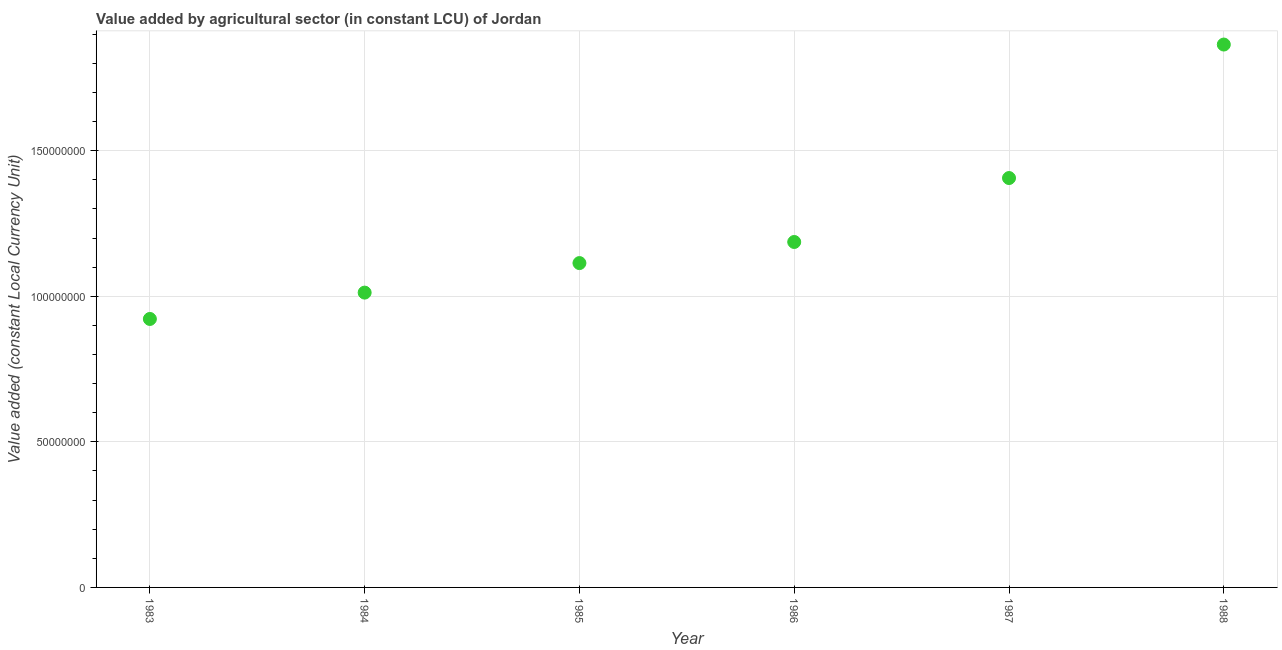What is the value added by agriculture sector in 1985?
Your answer should be compact. 1.11e+08. Across all years, what is the maximum value added by agriculture sector?
Offer a very short reply. 1.86e+08. Across all years, what is the minimum value added by agriculture sector?
Provide a succinct answer. 9.22e+07. In which year was the value added by agriculture sector minimum?
Keep it short and to the point. 1983. What is the sum of the value added by agriculture sector?
Your answer should be very brief. 7.51e+08. What is the difference between the value added by agriculture sector in 1986 and 1988?
Your answer should be compact. -6.78e+07. What is the average value added by agriculture sector per year?
Your response must be concise. 1.25e+08. What is the median value added by agriculture sector?
Provide a succinct answer. 1.15e+08. In how many years, is the value added by agriculture sector greater than 120000000 LCU?
Your answer should be compact. 2. What is the ratio of the value added by agriculture sector in 1985 to that in 1986?
Give a very brief answer. 0.94. Is the value added by agriculture sector in 1986 less than that in 1987?
Your response must be concise. Yes. Is the difference between the value added by agriculture sector in 1986 and 1987 greater than the difference between any two years?
Offer a terse response. No. What is the difference between the highest and the second highest value added by agriculture sector?
Your response must be concise. 4.59e+07. Is the sum of the value added by agriculture sector in 1986 and 1987 greater than the maximum value added by agriculture sector across all years?
Give a very brief answer. Yes. What is the difference between the highest and the lowest value added by agriculture sector?
Provide a succinct answer. 9.43e+07. In how many years, is the value added by agriculture sector greater than the average value added by agriculture sector taken over all years?
Offer a very short reply. 2. Does the value added by agriculture sector monotonically increase over the years?
Offer a terse response. Yes. How many dotlines are there?
Your answer should be very brief. 1. How many years are there in the graph?
Your answer should be very brief. 6. What is the title of the graph?
Your response must be concise. Value added by agricultural sector (in constant LCU) of Jordan. What is the label or title of the Y-axis?
Your response must be concise. Value added (constant Local Currency Unit). What is the Value added (constant Local Currency Unit) in 1983?
Give a very brief answer. 9.22e+07. What is the Value added (constant Local Currency Unit) in 1984?
Ensure brevity in your answer.  1.01e+08. What is the Value added (constant Local Currency Unit) in 1985?
Keep it short and to the point. 1.11e+08. What is the Value added (constant Local Currency Unit) in 1986?
Your answer should be very brief. 1.19e+08. What is the Value added (constant Local Currency Unit) in 1987?
Provide a succinct answer. 1.41e+08. What is the Value added (constant Local Currency Unit) in 1988?
Offer a terse response. 1.86e+08. What is the difference between the Value added (constant Local Currency Unit) in 1983 and 1984?
Give a very brief answer. -9.05e+06. What is the difference between the Value added (constant Local Currency Unit) in 1983 and 1985?
Offer a very short reply. -1.92e+07. What is the difference between the Value added (constant Local Currency Unit) in 1983 and 1986?
Offer a terse response. -2.64e+07. What is the difference between the Value added (constant Local Currency Unit) in 1983 and 1987?
Provide a succinct answer. -4.84e+07. What is the difference between the Value added (constant Local Currency Unit) in 1983 and 1988?
Ensure brevity in your answer.  -9.43e+07. What is the difference between the Value added (constant Local Currency Unit) in 1984 and 1985?
Your answer should be very brief. -1.01e+07. What is the difference between the Value added (constant Local Currency Unit) in 1984 and 1986?
Ensure brevity in your answer.  -1.74e+07. What is the difference between the Value added (constant Local Currency Unit) in 1984 and 1987?
Offer a very short reply. -3.94e+07. What is the difference between the Value added (constant Local Currency Unit) in 1984 and 1988?
Your answer should be compact. -8.52e+07. What is the difference between the Value added (constant Local Currency Unit) in 1985 and 1986?
Offer a terse response. -7.25e+06. What is the difference between the Value added (constant Local Currency Unit) in 1985 and 1987?
Your response must be concise. -2.92e+07. What is the difference between the Value added (constant Local Currency Unit) in 1985 and 1988?
Your answer should be compact. -7.51e+07. What is the difference between the Value added (constant Local Currency Unit) in 1986 and 1987?
Keep it short and to the point. -2.20e+07. What is the difference between the Value added (constant Local Currency Unit) in 1986 and 1988?
Your answer should be compact. -6.78e+07. What is the difference between the Value added (constant Local Currency Unit) in 1987 and 1988?
Give a very brief answer. -4.59e+07. What is the ratio of the Value added (constant Local Currency Unit) in 1983 to that in 1984?
Give a very brief answer. 0.91. What is the ratio of the Value added (constant Local Currency Unit) in 1983 to that in 1985?
Provide a succinct answer. 0.83. What is the ratio of the Value added (constant Local Currency Unit) in 1983 to that in 1986?
Your answer should be very brief. 0.78. What is the ratio of the Value added (constant Local Currency Unit) in 1983 to that in 1987?
Your response must be concise. 0.66. What is the ratio of the Value added (constant Local Currency Unit) in 1983 to that in 1988?
Offer a terse response. 0.49. What is the ratio of the Value added (constant Local Currency Unit) in 1984 to that in 1985?
Provide a succinct answer. 0.91. What is the ratio of the Value added (constant Local Currency Unit) in 1984 to that in 1986?
Keep it short and to the point. 0.85. What is the ratio of the Value added (constant Local Currency Unit) in 1984 to that in 1987?
Give a very brief answer. 0.72. What is the ratio of the Value added (constant Local Currency Unit) in 1984 to that in 1988?
Ensure brevity in your answer.  0.54. What is the ratio of the Value added (constant Local Currency Unit) in 1985 to that in 1986?
Your response must be concise. 0.94. What is the ratio of the Value added (constant Local Currency Unit) in 1985 to that in 1987?
Offer a very short reply. 0.79. What is the ratio of the Value added (constant Local Currency Unit) in 1985 to that in 1988?
Make the answer very short. 0.6. What is the ratio of the Value added (constant Local Currency Unit) in 1986 to that in 1987?
Your answer should be very brief. 0.84. What is the ratio of the Value added (constant Local Currency Unit) in 1986 to that in 1988?
Ensure brevity in your answer.  0.64. What is the ratio of the Value added (constant Local Currency Unit) in 1987 to that in 1988?
Your response must be concise. 0.75. 